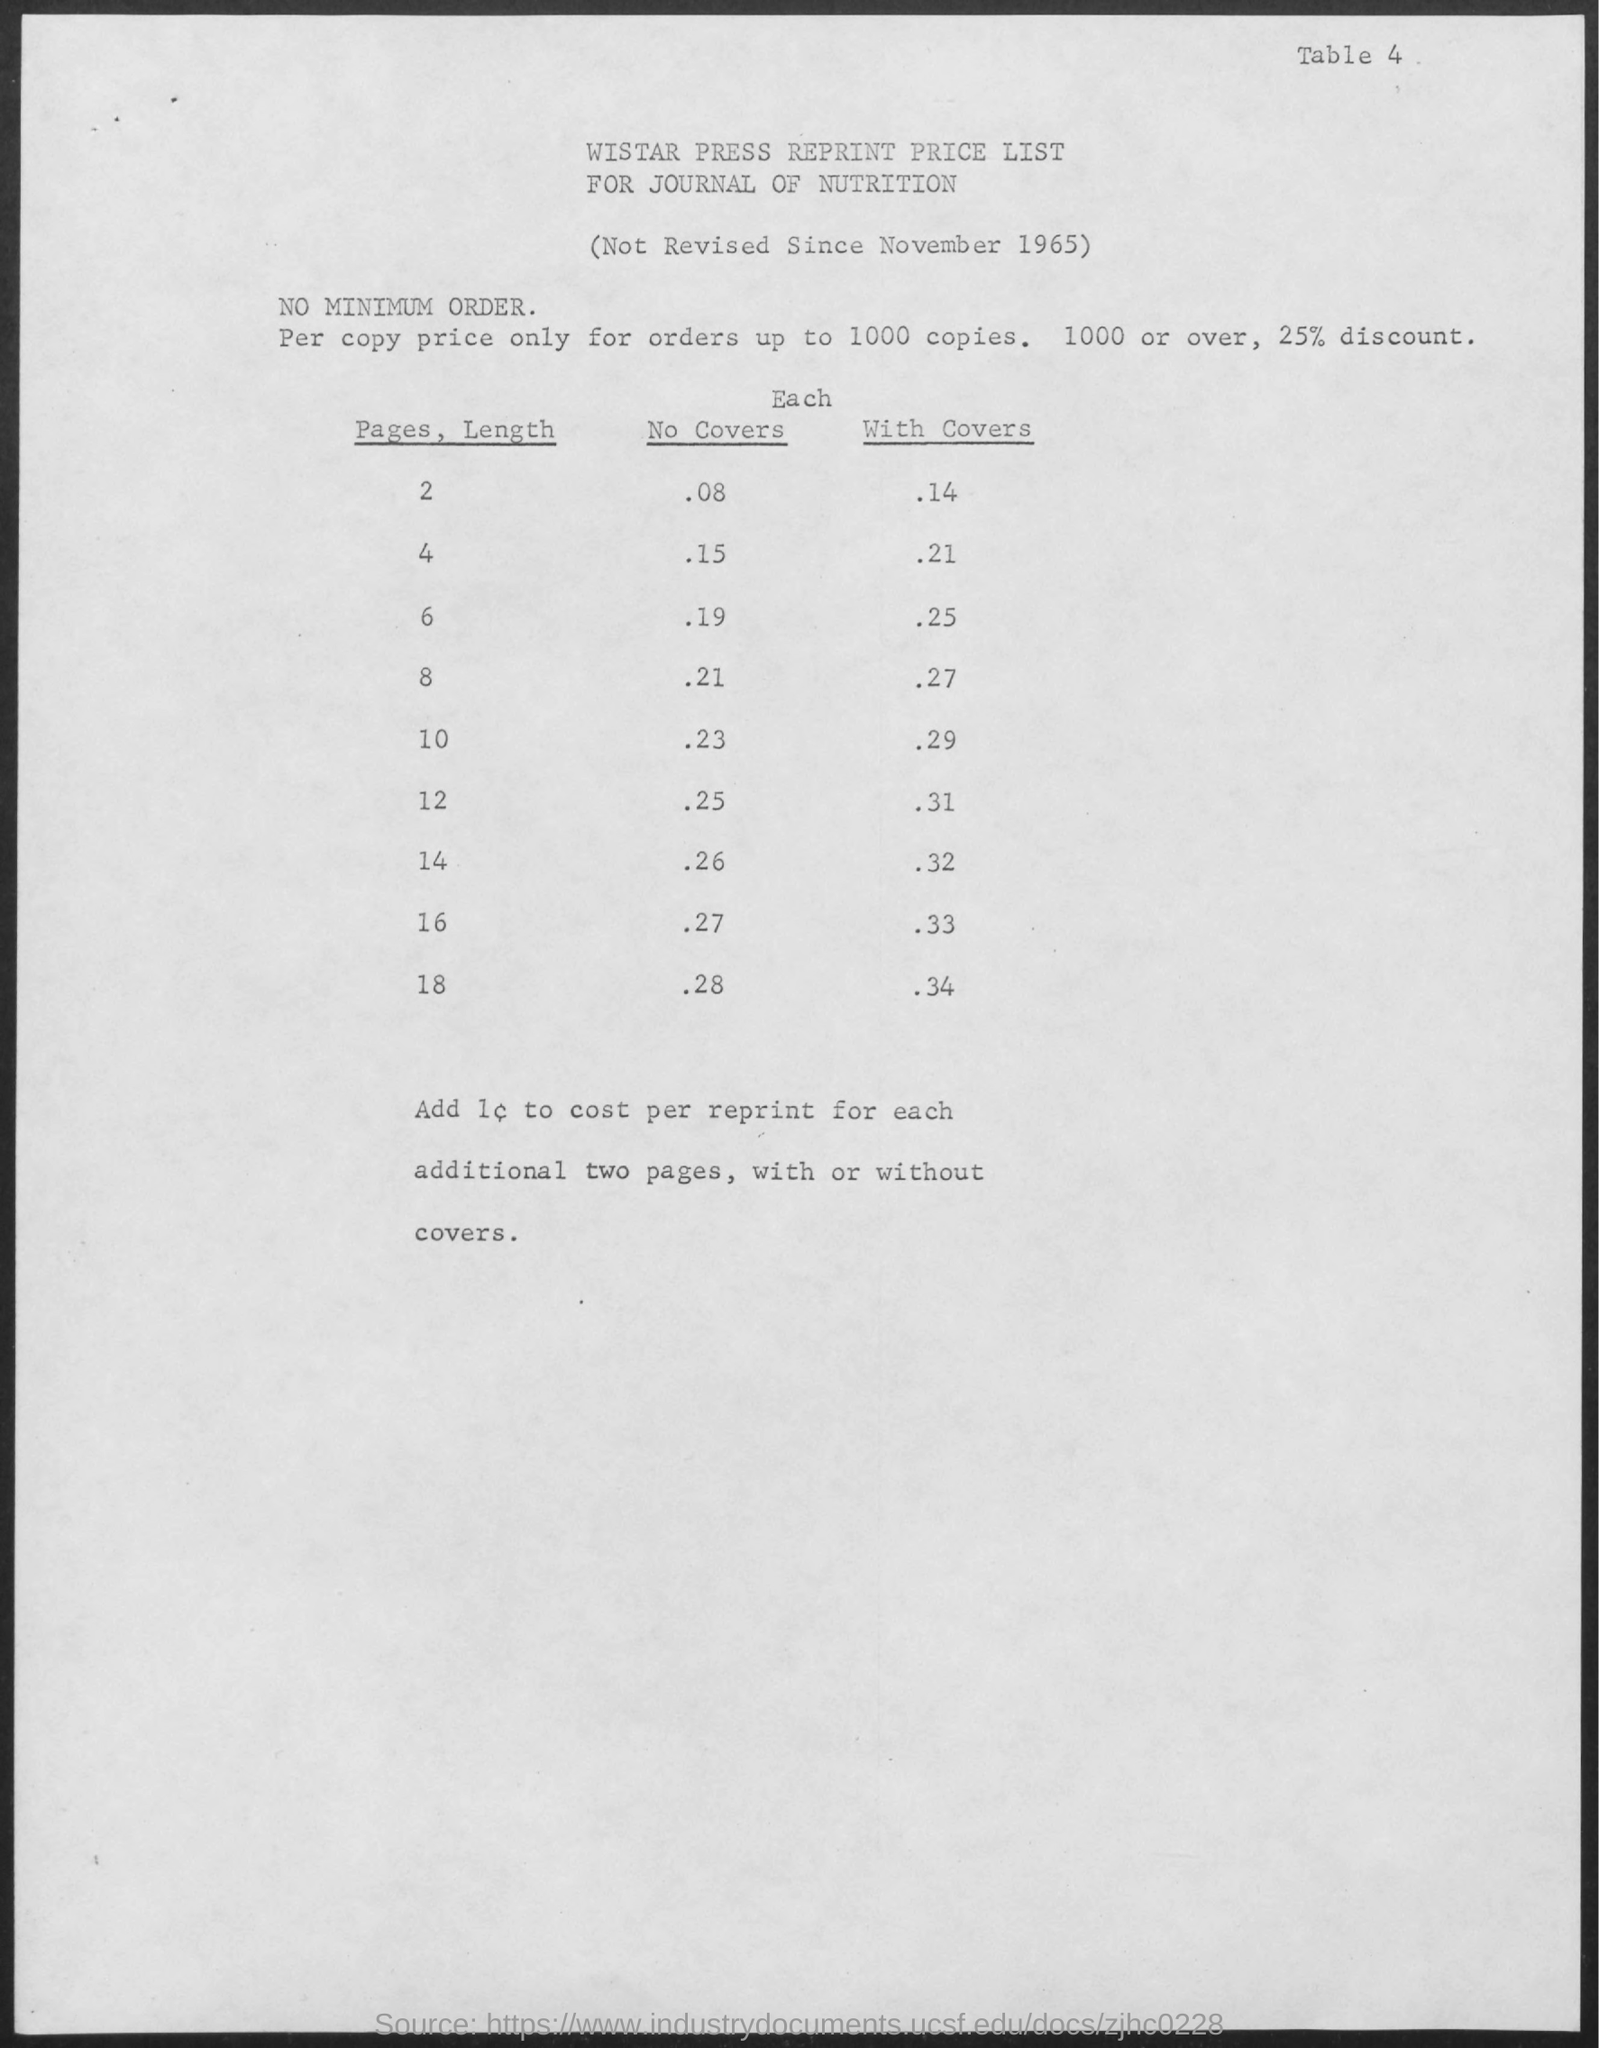Identify some key points in this picture. The title of the document is "Wistar Press Reprint Price List for Journal of Nutrition. 